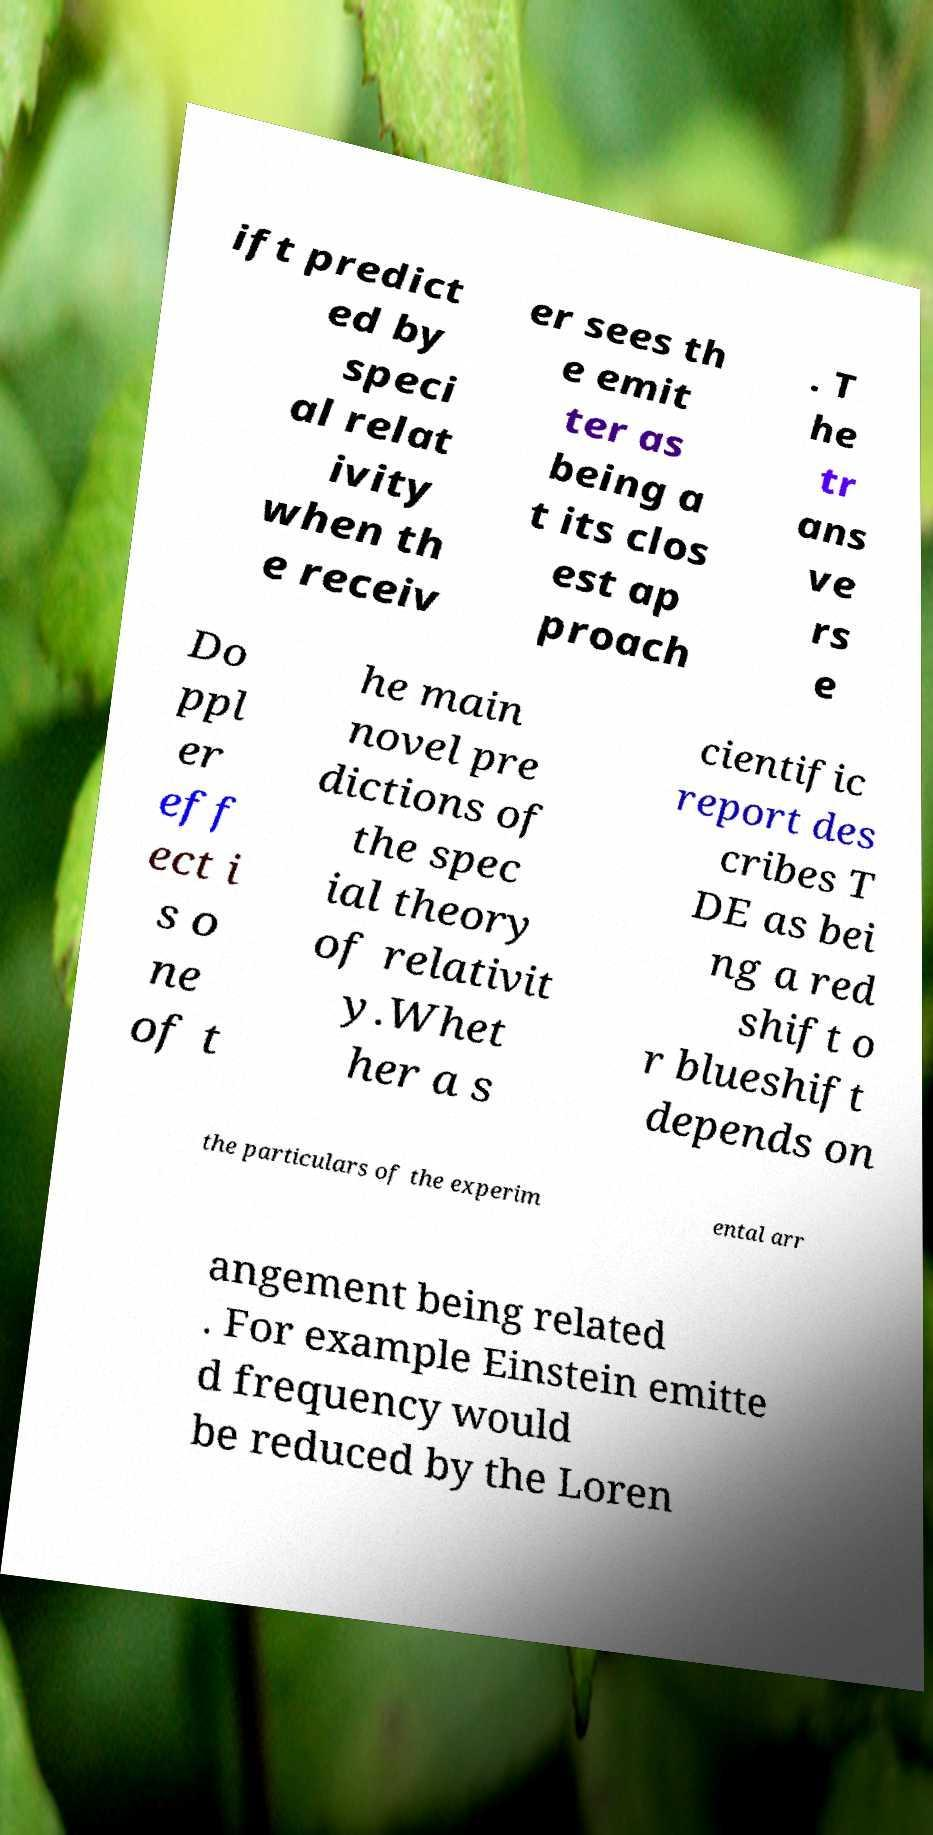What messages or text are displayed in this image? I need them in a readable, typed format. ift predict ed by speci al relat ivity when th e receiv er sees th e emit ter as being a t its clos est ap proach . T he tr ans ve rs e Do ppl er eff ect i s o ne of t he main novel pre dictions of the spec ial theory of relativit y.Whet her a s cientific report des cribes T DE as bei ng a red shift o r blueshift depends on the particulars of the experim ental arr angement being related . For example Einstein emitte d frequency would be reduced by the Loren 